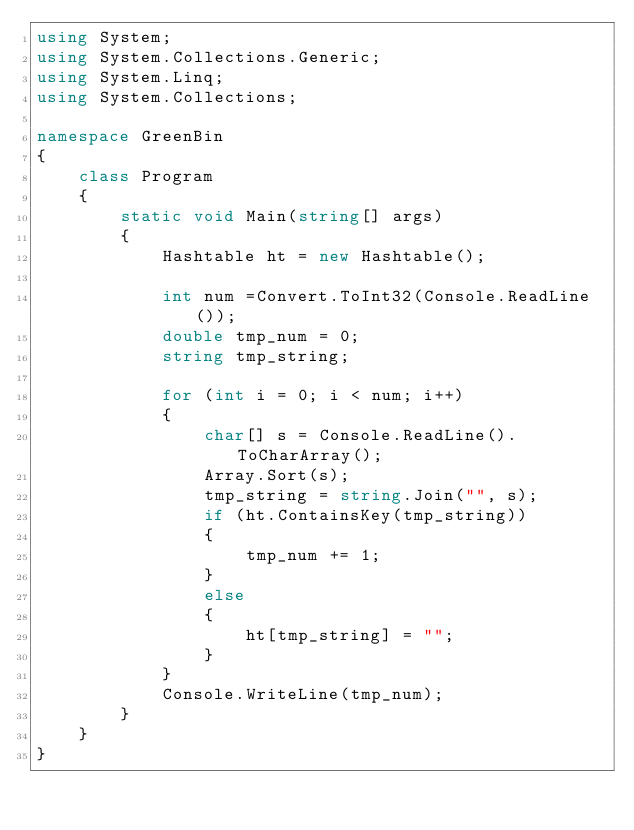<code> <loc_0><loc_0><loc_500><loc_500><_C#_>using System;
using System.Collections.Generic;
using System.Linq;
using System.Collections;

namespace GreenBin
{
    class Program
    {
        static void Main(string[] args)
        {
            Hashtable ht = new Hashtable();

            int num =Convert.ToInt32(Console.ReadLine());
            double tmp_num = 0;
            string tmp_string;

            for (int i = 0; i < num; i++)
            {
                char[] s = Console.ReadLine().ToCharArray();
                Array.Sort(s);
                tmp_string = string.Join("", s);
                if (ht.ContainsKey(tmp_string))
                {
                    tmp_num += 1;
                }
                else
                {
                    ht[tmp_string] = "";
                }
            }
            Console.WriteLine(tmp_num);
        }
    }
}
</code> 